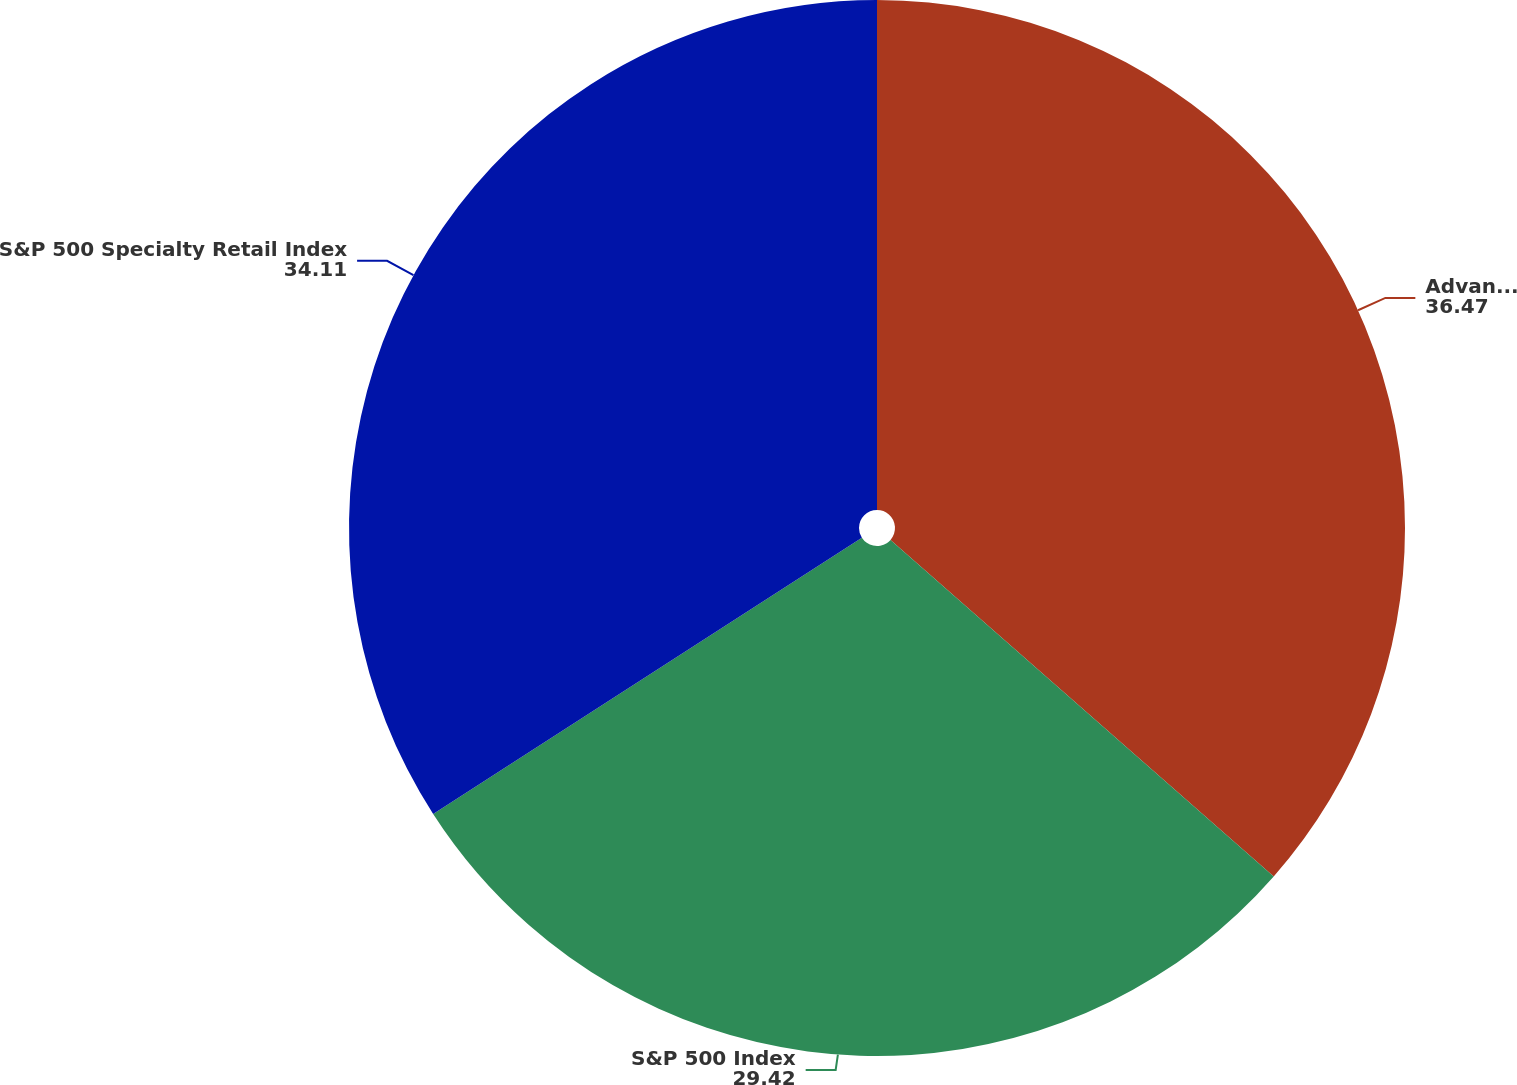Convert chart. <chart><loc_0><loc_0><loc_500><loc_500><pie_chart><fcel>Advance Auto Parts<fcel>S&P 500 Index<fcel>S&P 500 Specialty Retail Index<nl><fcel>36.47%<fcel>29.42%<fcel>34.11%<nl></chart> 